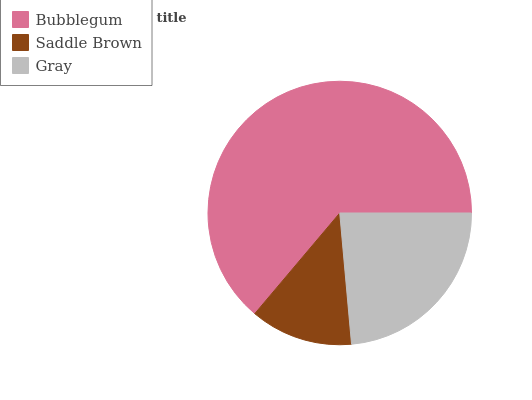Is Saddle Brown the minimum?
Answer yes or no. Yes. Is Bubblegum the maximum?
Answer yes or no. Yes. Is Gray the minimum?
Answer yes or no. No. Is Gray the maximum?
Answer yes or no. No. Is Gray greater than Saddle Brown?
Answer yes or no. Yes. Is Saddle Brown less than Gray?
Answer yes or no. Yes. Is Saddle Brown greater than Gray?
Answer yes or no. No. Is Gray less than Saddle Brown?
Answer yes or no. No. Is Gray the high median?
Answer yes or no. Yes. Is Gray the low median?
Answer yes or no. Yes. Is Saddle Brown the high median?
Answer yes or no. No. Is Saddle Brown the low median?
Answer yes or no. No. 